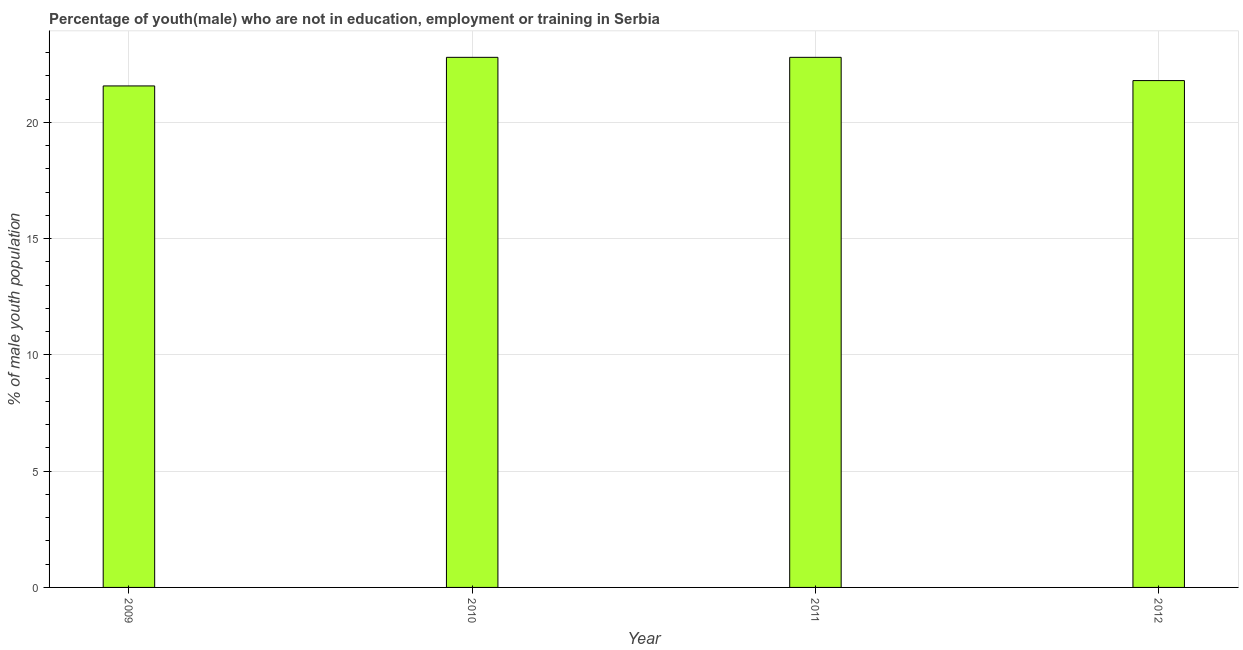Does the graph contain any zero values?
Your response must be concise. No. Does the graph contain grids?
Your response must be concise. Yes. What is the title of the graph?
Offer a terse response. Percentage of youth(male) who are not in education, employment or training in Serbia. What is the label or title of the Y-axis?
Provide a short and direct response. % of male youth population. What is the unemployed male youth population in 2012?
Your response must be concise. 21.8. Across all years, what is the maximum unemployed male youth population?
Offer a very short reply. 22.8. Across all years, what is the minimum unemployed male youth population?
Your response must be concise. 21.57. In which year was the unemployed male youth population maximum?
Your response must be concise. 2010. What is the sum of the unemployed male youth population?
Ensure brevity in your answer.  88.97. What is the difference between the unemployed male youth population in 2009 and 2010?
Your answer should be very brief. -1.23. What is the average unemployed male youth population per year?
Keep it short and to the point. 22.24. What is the median unemployed male youth population?
Provide a short and direct response. 22.3. Do a majority of the years between 2009 and 2012 (inclusive) have unemployed male youth population greater than 16 %?
Offer a very short reply. Yes. What is the ratio of the unemployed male youth population in 2009 to that in 2010?
Your answer should be compact. 0.95. Is the unemployed male youth population in 2010 less than that in 2012?
Provide a succinct answer. No. Is the difference between the unemployed male youth population in 2011 and 2012 greater than the difference between any two years?
Provide a succinct answer. No. Is the sum of the unemployed male youth population in 2009 and 2011 greater than the maximum unemployed male youth population across all years?
Your response must be concise. Yes. What is the difference between the highest and the lowest unemployed male youth population?
Give a very brief answer. 1.23. How many bars are there?
Make the answer very short. 4. How many years are there in the graph?
Ensure brevity in your answer.  4. What is the difference between two consecutive major ticks on the Y-axis?
Your answer should be compact. 5. What is the % of male youth population of 2009?
Your response must be concise. 21.57. What is the % of male youth population of 2010?
Ensure brevity in your answer.  22.8. What is the % of male youth population of 2011?
Provide a succinct answer. 22.8. What is the % of male youth population of 2012?
Your answer should be very brief. 21.8. What is the difference between the % of male youth population in 2009 and 2010?
Keep it short and to the point. -1.23. What is the difference between the % of male youth population in 2009 and 2011?
Your answer should be very brief. -1.23. What is the difference between the % of male youth population in 2009 and 2012?
Give a very brief answer. -0.23. What is the difference between the % of male youth population in 2010 and 2011?
Your response must be concise. 0. What is the ratio of the % of male youth population in 2009 to that in 2010?
Keep it short and to the point. 0.95. What is the ratio of the % of male youth population in 2009 to that in 2011?
Make the answer very short. 0.95. What is the ratio of the % of male youth population in 2010 to that in 2012?
Offer a very short reply. 1.05. What is the ratio of the % of male youth population in 2011 to that in 2012?
Offer a terse response. 1.05. 